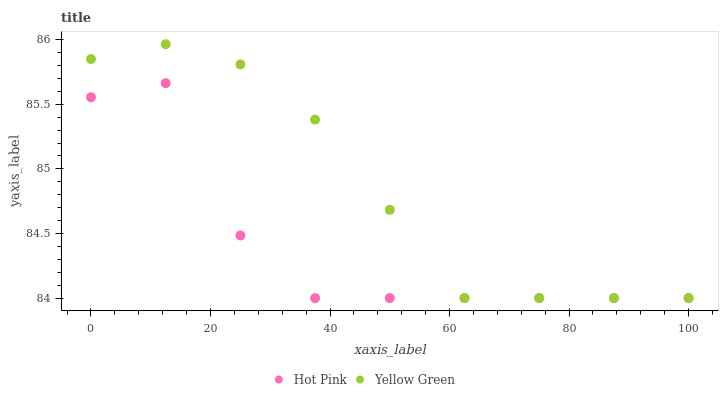Does Hot Pink have the minimum area under the curve?
Answer yes or no. Yes. Does Yellow Green have the maximum area under the curve?
Answer yes or no. Yes. Does Yellow Green have the minimum area under the curve?
Answer yes or no. No. Is Yellow Green the smoothest?
Answer yes or no. Yes. Is Hot Pink the roughest?
Answer yes or no. Yes. Is Yellow Green the roughest?
Answer yes or no. No. Does Hot Pink have the lowest value?
Answer yes or no. Yes. Does Yellow Green have the highest value?
Answer yes or no. Yes. Does Hot Pink intersect Yellow Green?
Answer yes or no. Yes. Is Hot Pink less than Yellow Green?
Answer yes or no. No. Is Hot Pink greater than Yellow Green?
Answer yes or no. No. 